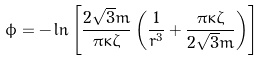Convert formula to latex. <formula><loc_0><loc_0><loc_500><loc_500>\phi = - \ln \left [ \frac { 2 \sqrt { 3 } m } { \pi \kappa \zeta } \left ( \frac { 1 } { r ^ { 3 } } + \frac { \pi \kappa \zeta } { 2 \sqrt { 3 } m } \right ) \right ]</formula> 